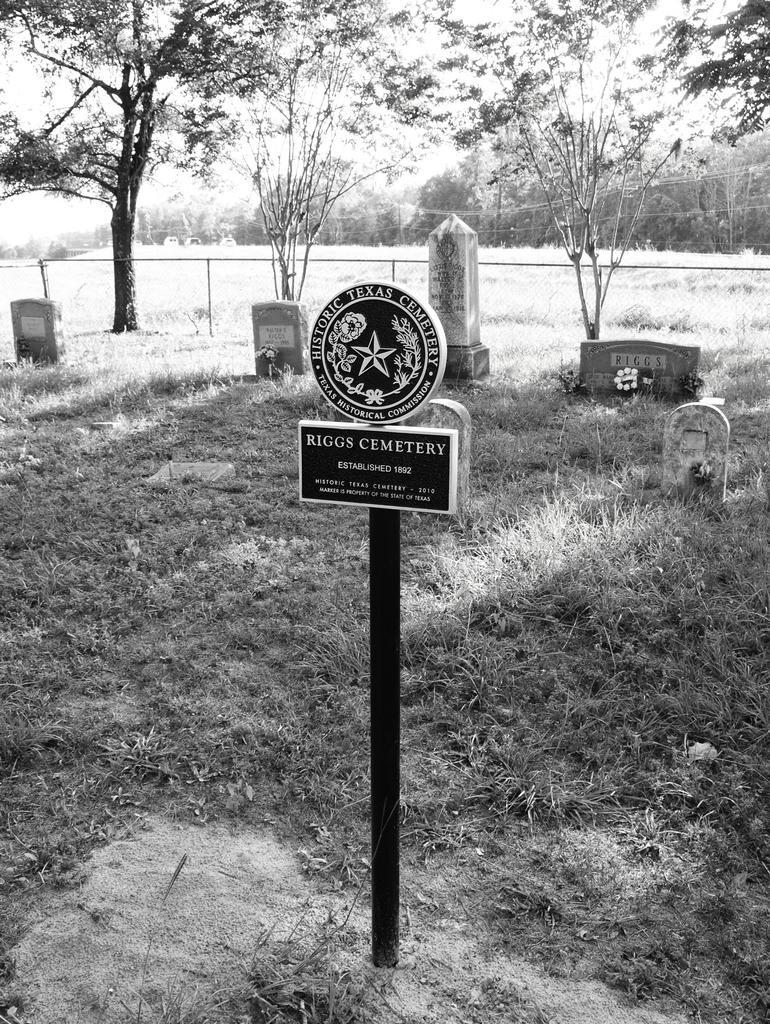Please provide a concise description of this image. This is a black and white image. In this image we can see a black color rod with some text on it. In the background of the image there are trees. There are graves. At the bottom of the image there is grass. 